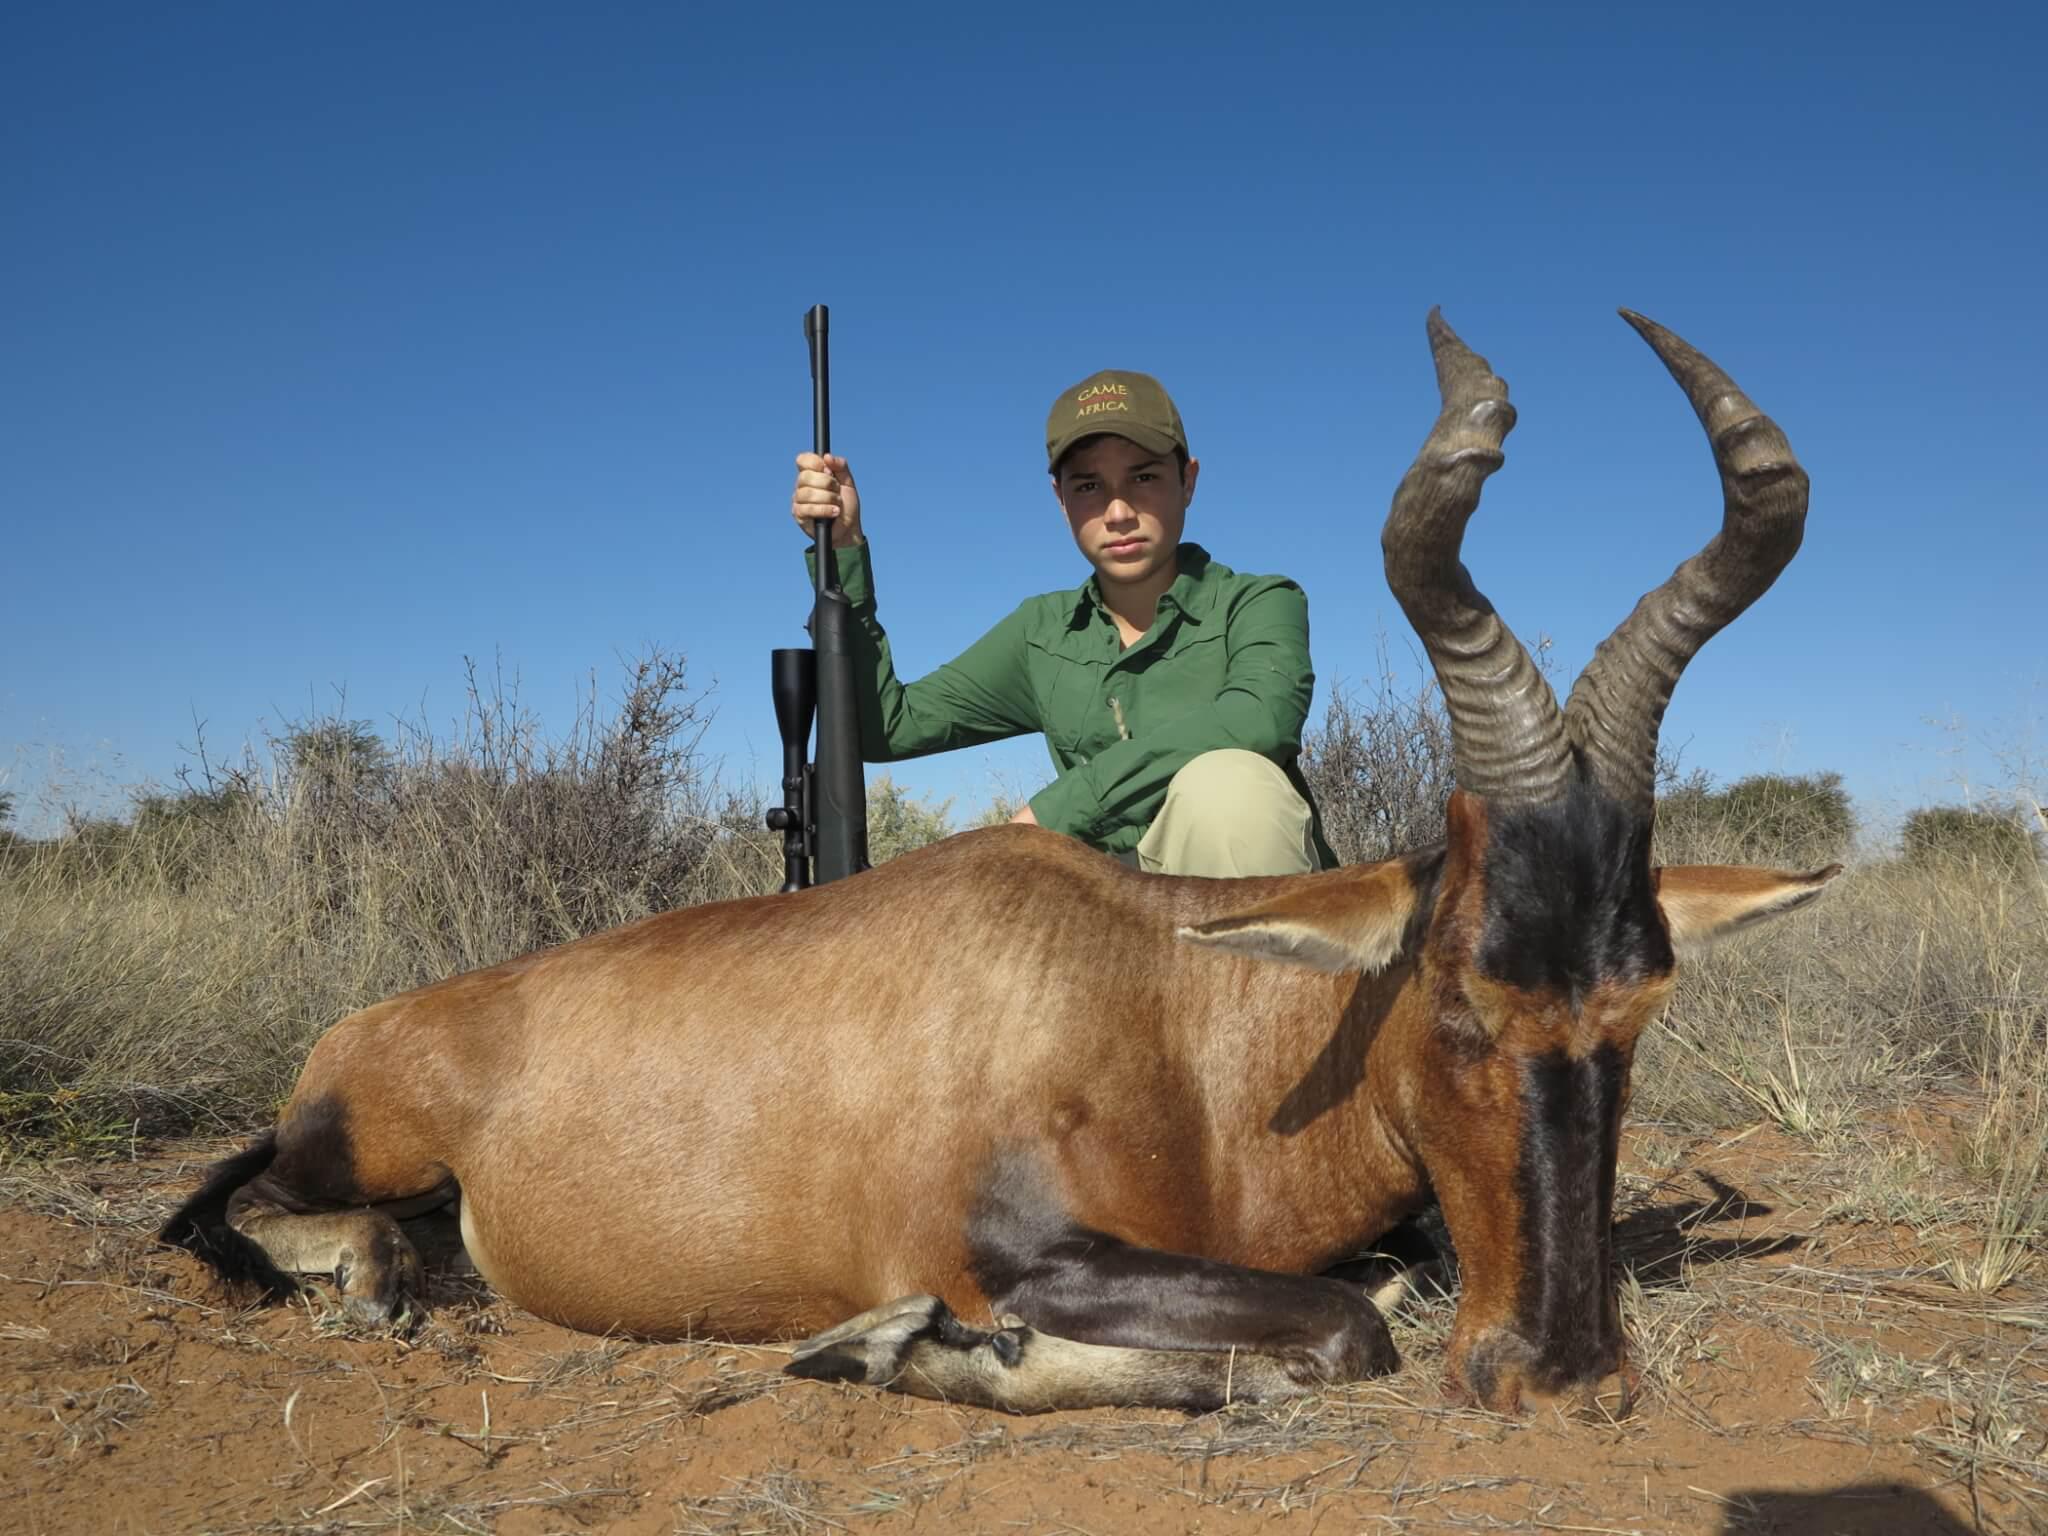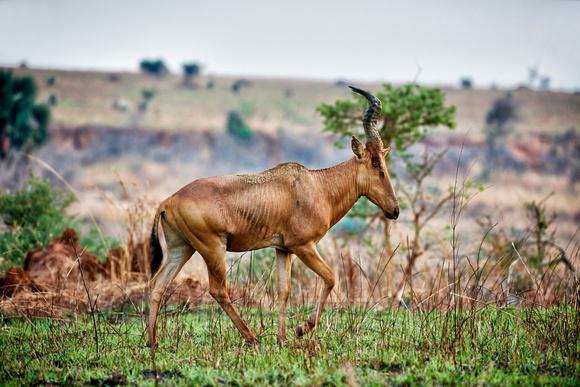The first image is the image on the left, the second image is the image on the right. Considering the images on both sides, is "In one image, a hunter in a hat holding a rifle vertically is behind a downed horned animal with its head to the right." valid? Answer yes or no. Yes. The first image is the image on the left, the second image is the image on the right. For the images displayed, is the sentence "Exactly one animal is lying on the ground." factually correct? Answer yes or no. Yes. 